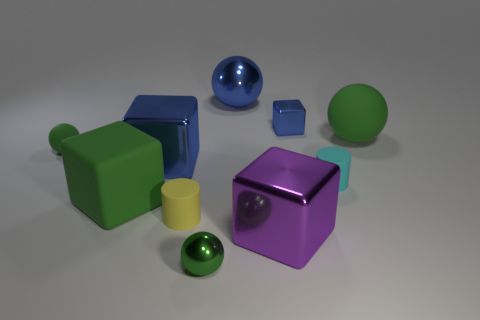Subtract all blue cylinders. How many green spheres are left? 3 Subtract all balls. How many objects are left? 6 Subtract all big blue shiny balls. Subtract all large metallic things. How many objects are left? 6 Add 3 large rubber cubes. How many large rubber cubes are left? 4 Add 9 brown metal cubes. How many brown metal cubes exist? 9 Subtract 2 green spheres. How many objects are left? 8 